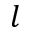<formula> <loc_0><loc_0><loc_500><loc_500>l</formula> 